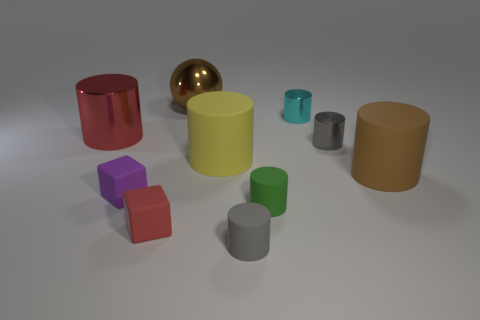There is a object that is to the right of the gray shiny object; is it the same color as the large metal sphere behind the big metal cylinder?
Make the answer very short. Yes. What size is the block that is the same color as the large metallic cylinder?
Your answer should be very brief. Small. What number of large things are the same color as the big sphere?
Your answer should be compact. 1. What size is the brown thing that is the same material as the cyan cylinder?
Keep it short and to the point. Large. What number of objects are either small things that are in front of the big metallic cylinder or yellow cylinders?
Your answer should be compact. 6. There is a small cube that is in front of the purple object; is its color the same as the big shiny cylinder?
Offer a very short reply. Yes. The yellow rubber thing that is the same shape as the cyan object is what size?
Make the answer very short. Large. What is the color of the metal cylinder in front of the shiny cylinder that is to the left of the large shiny object that is right of the red metal cylinder?
Provide a short and direct response. Gray. Are the big brown cylinder and the tiny cyan object made of the same material?
Your answer should be compact. No. Is there a block that is behind the tiny cylinder that is behind the red object that is behind the tiny red matte block?
Offer a terse response. No. 